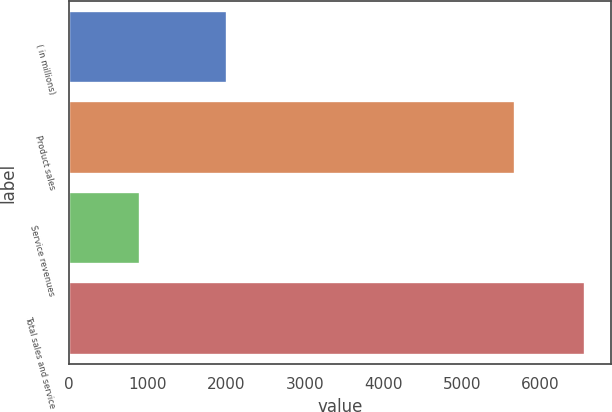<chart> <loc_0><loc_0><loc_500><loc_500><bar_chart><fcel>( in millions)<fcel>Product sales<fcel>Service revenues<fcel>Total sales and service<nl><fcel>2011<fcel>5676<fcel>899<fcel>6575<nl></chart> 